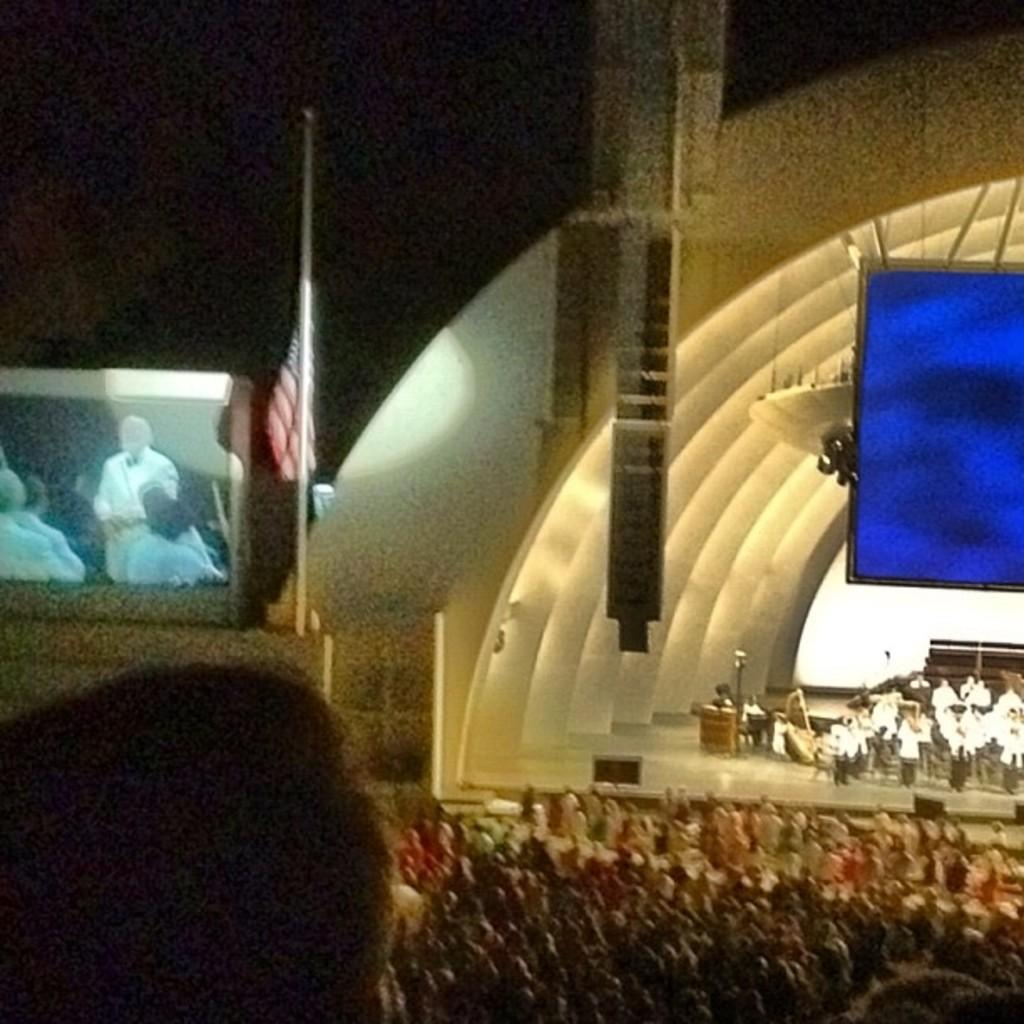What are the people in the image doing? The people in the image are standing on the stage. Where are the spectators located in the image? The spectators are sitting on chairs in the image. What is the purpose of the projector screen in the image? The projector screen is used for displaying visuals or information. What is located beside the projector screen? There is a flag beside the projector screen. Can you see the tail of the wire in the image? There is no wire present in the image, and therefore no tail to be seen. 